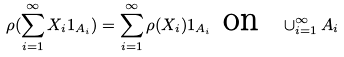Convert formula to latex. <formula><loc_0><loc_0><loc_500><loc_500>\rho ( \sum _ { i = 1 } ^ { \infty } X _ { i } 1 _ { A _ { i } } ) = \sum _ { i = 1 } ^ { \infty } \rho ( X _ { i } ) 1 _ { A _ { i } } \text { on \ } \cup _ { i = 1 } ^ { \infty } A _ { i }</formula> 